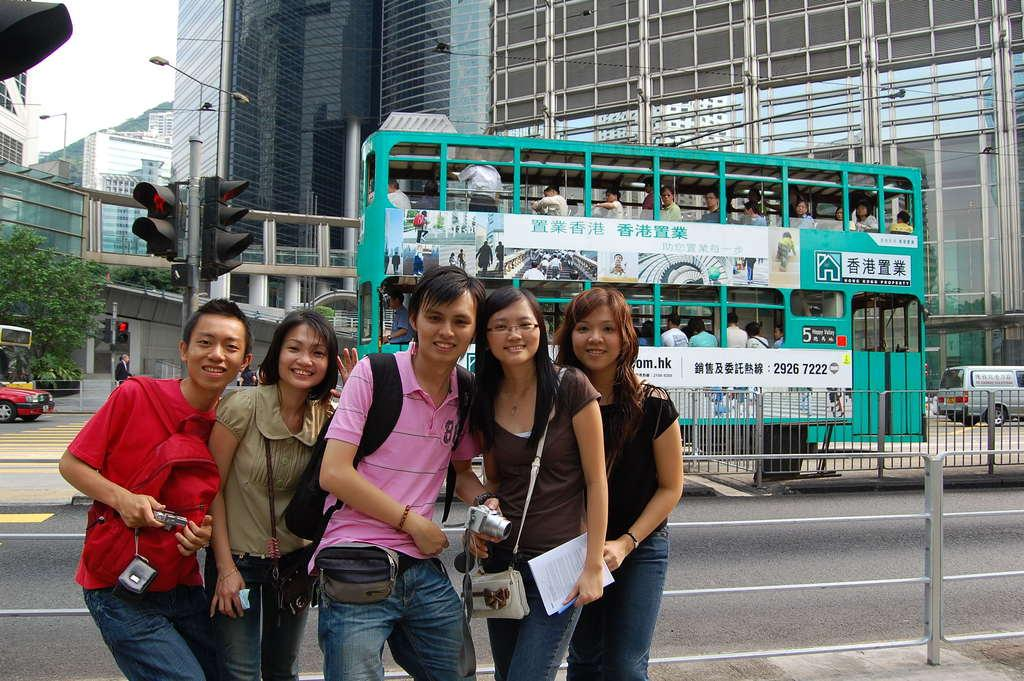<image>
Offer a succinct explanation of the picture presented. A group of people are posing for a picture in front of a bus with the number 5 on it. 